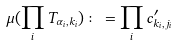<formula> <loc_0><loc_0><loc_500><loc_500>\mu ( \prod _ { i } T _ { \alpha _ { i } , k _ { i } } ) \colon = \prod _ { i } c ^ { \prime } _ { k _ { i } , j _ { i } }</formula> 